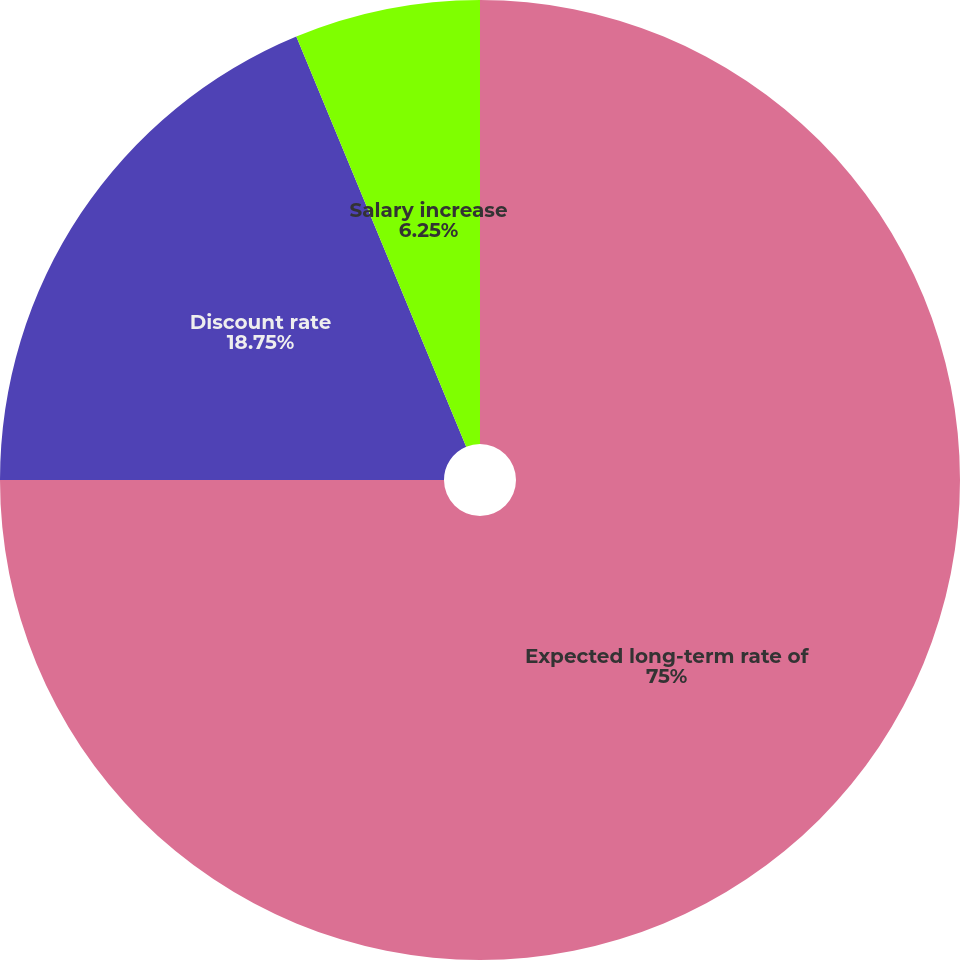Convert chart. <chart><loc_0><loc_0><loc_500><loc_500><pie_chart><fcel>Expected long-term rate of<fcel>Discount rate<fcel>Salary increase<nl><fcel>75.0%<fcel>18.75%<fcel>6.25%<nl></chart> 